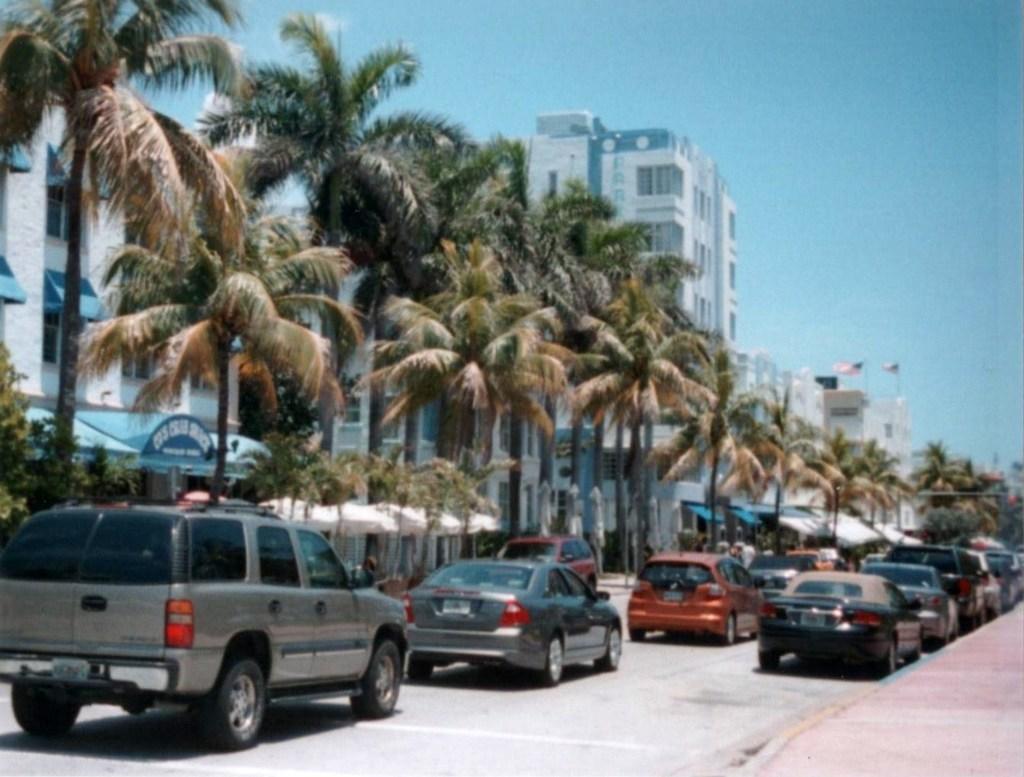Could you give a brief overview of what you see in this image? In this image we can see there are vehicles on the road and there is a sidewalk. And at the left side there are trees, buildings, umbrellas, flags and the sky. 